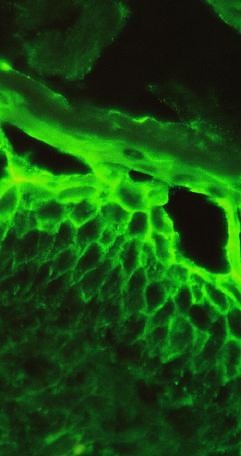what are confined to superficial layers of the epidermis?
Answer the question using a single word or phrase. Immunoglobulin deposits 